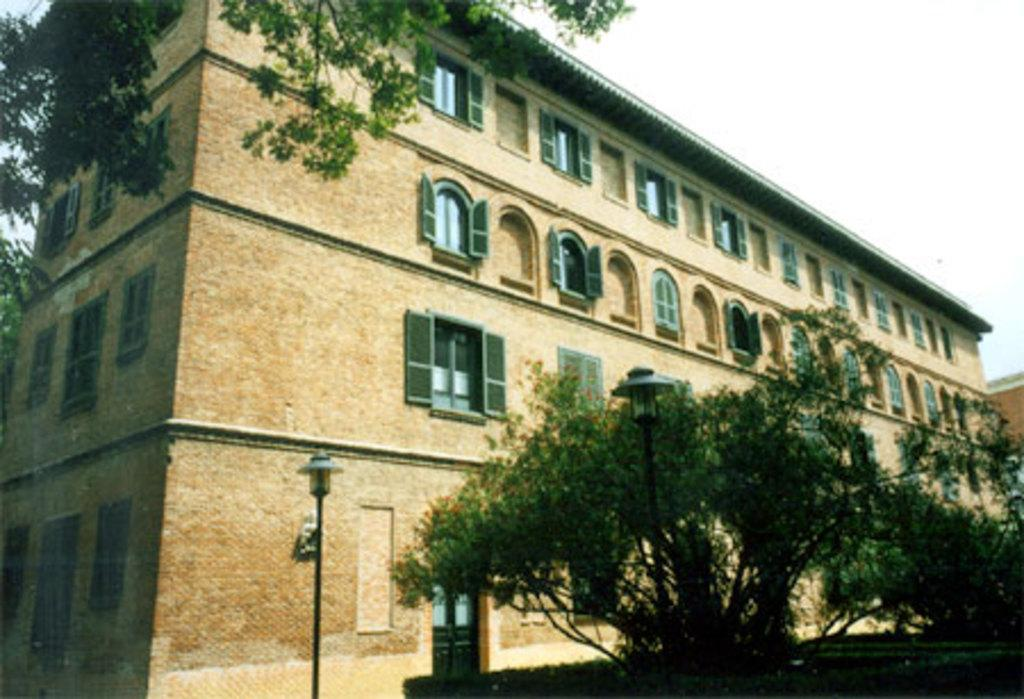What type of building is in the image? There is an old building in the image. What material is the building made of? The building is made of stone walls. What architectural features can be seen on the building? The building has windows. What is present around the building? Trees are present around the building. What other objects can be seen in the image? Lamp poles are visible in the image. How would you describe the lighting in the image? The sky is bright in the image. Can you see any leaves falling from the trees in the image? There is no mention of leaves falling from the trees in the image. Is there a stove visible in the image? There is no stove present in the image. 